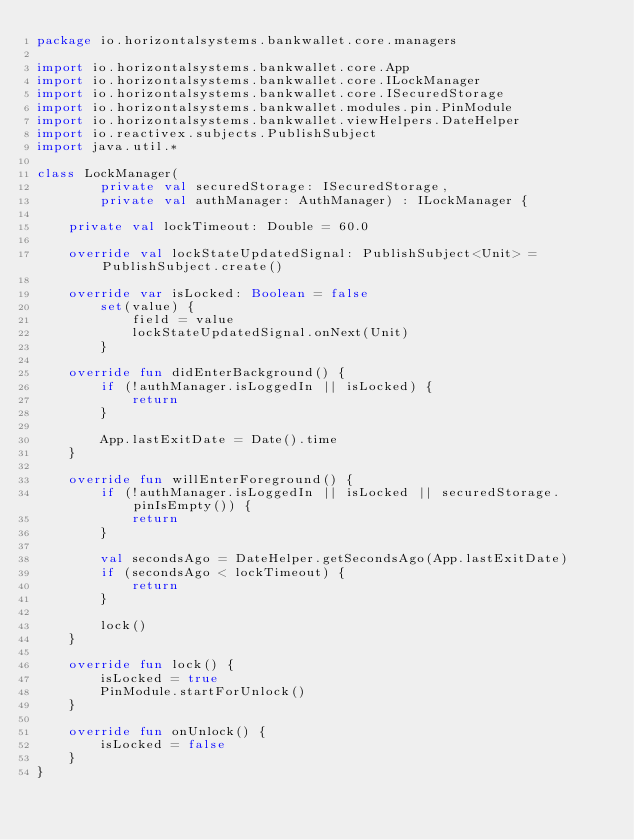Convert code to text. <code><loc_0><loc_0><loc_500><loc_500><_Kotlin_>package io.horizontalsystems.bankwallet.core.managers

import io.horizontalsystems.bankwallet.core.App
import io.horizontalsystems.bankwallet.core.ILockManager
import io.horizontalsystems.bankwallet.core.ISecuredStorage
import io.horizontalsystems.bankwallet.modules.pin.PinModule
import io.horizontalsystems.bankwallet.viewHelpers.DateHelper
import io.reactivex.subjects.PublishSubject
import java.util.*

class LockManager(
        private val securedStorage: ISecuredStorage,
        private val authManager: AuthManager) : ILockManager {

    private val lockTimeout: Double = 60.0

    override val lockStateUpdatedSignal: PublishSubject<Unit> = PublishSubject.create()

    override var isLocked: Boolean = false
        set(value) {
            field = value
            lockStateUpdatedSignal.onNext(Unit)
        }

    override fun didEnterBackground() {
        if (!authManager.isLoggedIn || isLocked) {
            return
        }

        App.lastExitDate = Date().time
    }

    override fun willEnterForeground() {
        if (!authManager.isLoggedIn || isLocked || securedStorage.pinIsEmpty()) {
            return
        }

        val secondsAgo = DateHelper.getSecondsAgo(App.lastExitDate)
        if (secondsAgo < lockTimeout) {
            return
        }

        lock()
    }

    override fun lock() {
        isLocked = true
        PinModule.startForUnlock()
    }

    override fun onUnlock() {
        isLocked = false
    }
}
</code> 